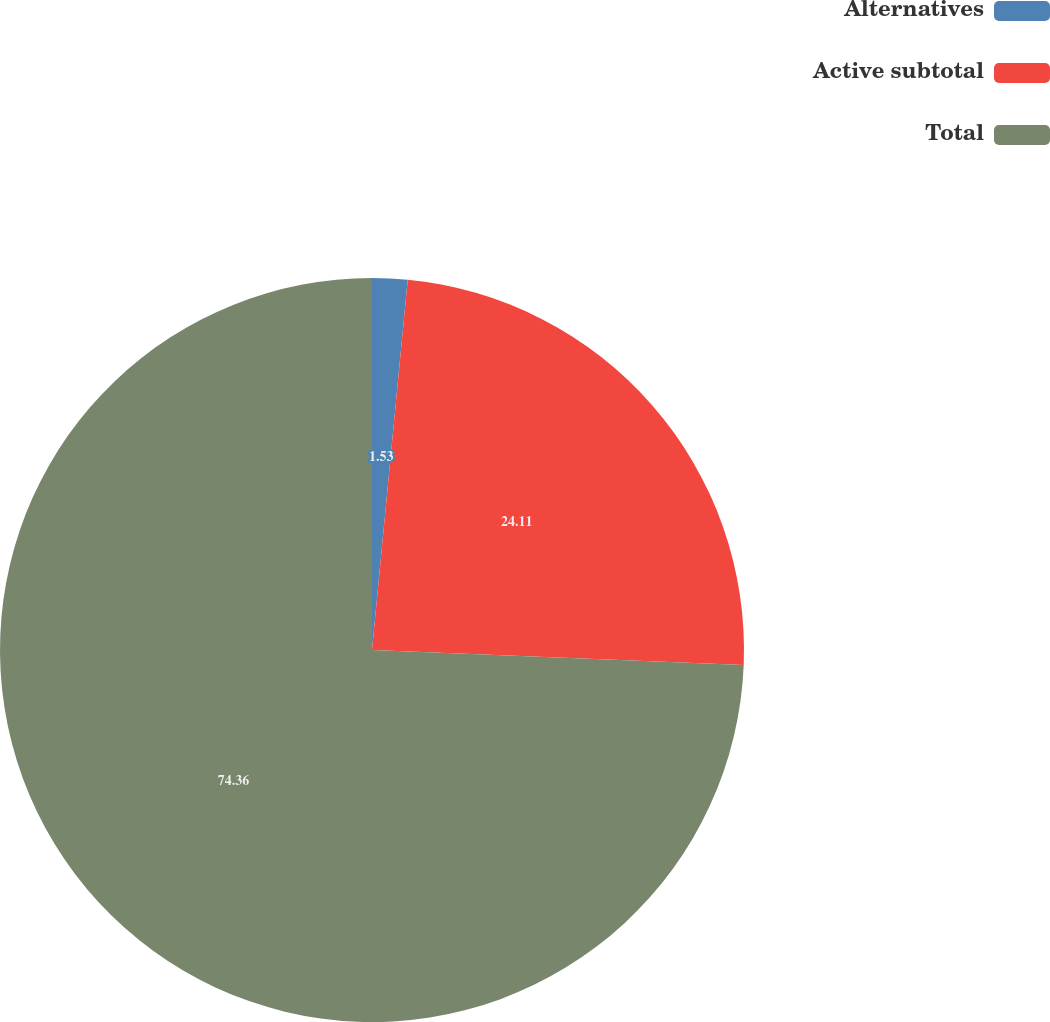Convert chart. <chart><loc_0><loc_0><loc_500><loc_500><pie_chart><fcel>Alternatives<fcel>Active subtotal<fcel>Total<nl><fcel>1.53%<fcel>24.11%<fcel>74.36%<nl></chart> 